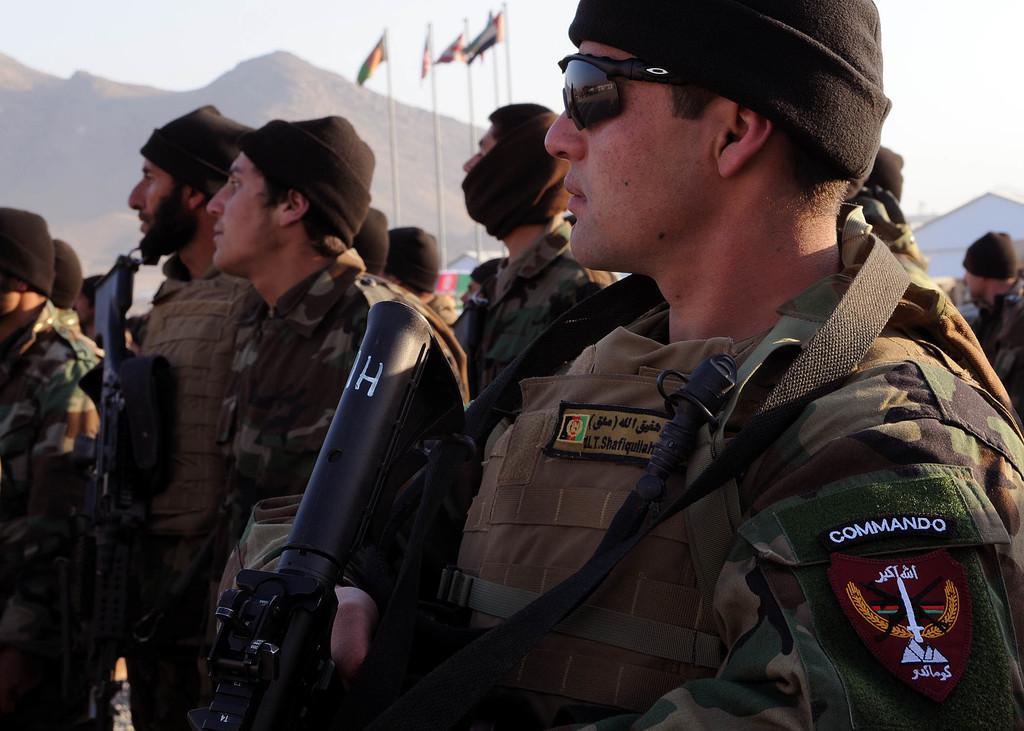Please provide a concise description of this image. In this picture I can see few people are standing and few of them wore caps on their heads and I can see they are holding guns in their hands and I can see few flagpoles and I can see hill in the back and a house and I can see cloudy sky. 